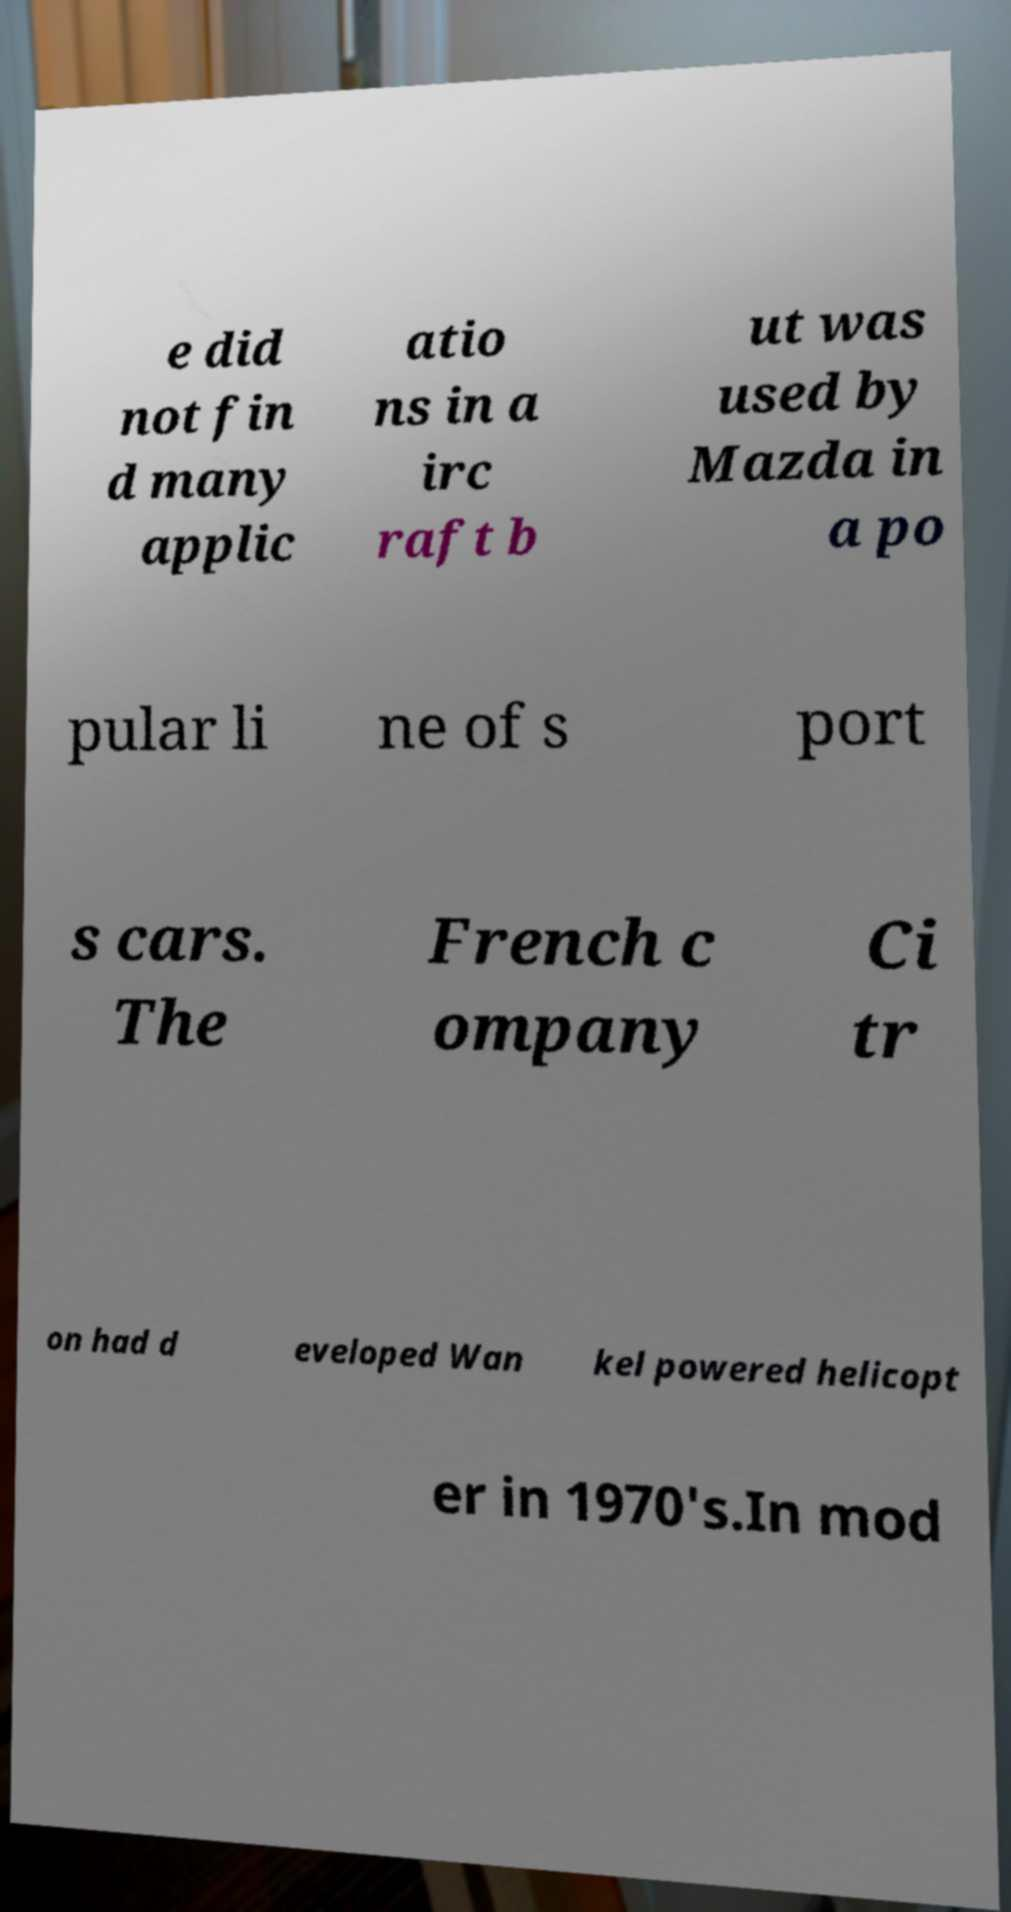Please identify and transcribe the text found in this image. e did not fin d many applic atio ns in a irc raft b ut was used by Mazda in a po pular li ne of s port s cars. The French c ompany Ci tr on had d eveloped Wan kel powered helicopt er in 1970's.In mod 